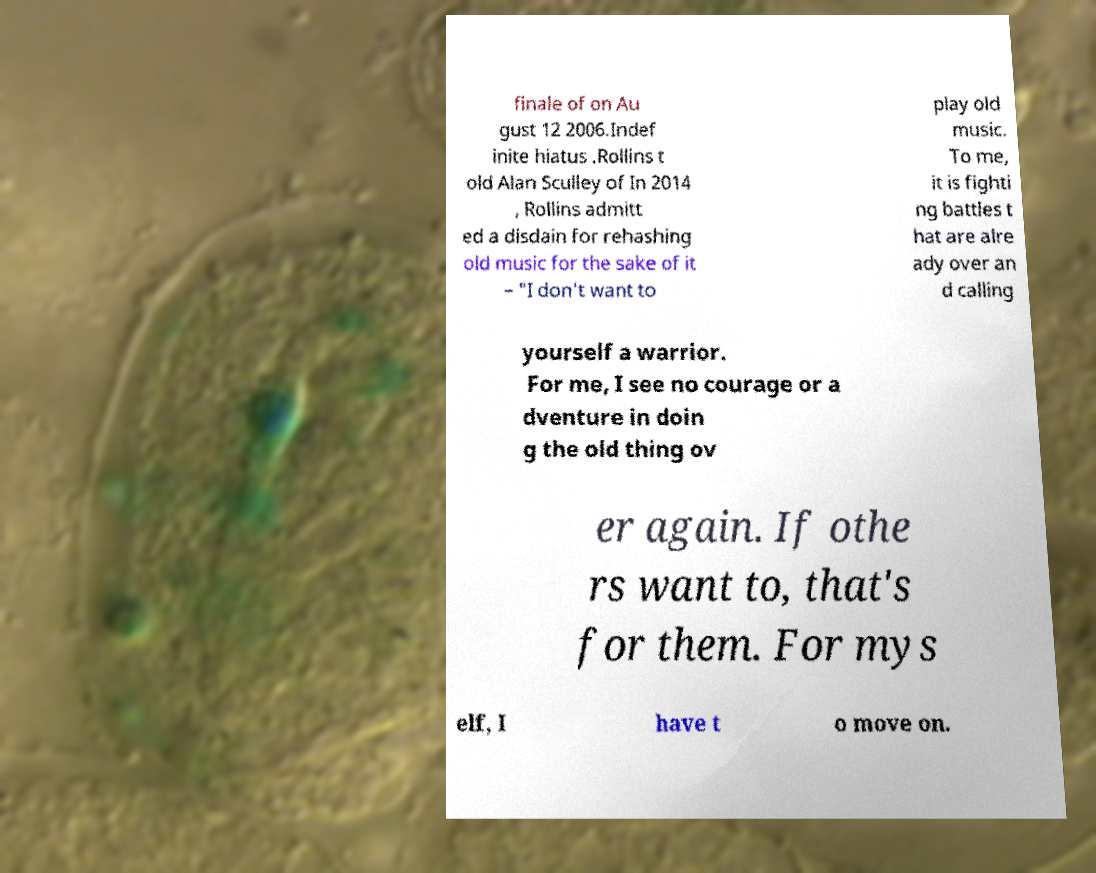Could you assist in decoding the text presented in this image and type it out clearly? finale of on Au gust 12 2006.Indef inite hiatus .Rollins t old Alan Sculley of In 2014 , Rollins admitt ed a disdain for rehashing old music for the sake of it – "I don't want to play old music. To me, it is fighti ng battles t hat are alre ady over an d calling yourself a warrior. For me, I see no courage or a dventure in doin g the old thing ov er again. If othe rs want to, that's for them. For mys elf, I have t o move on. 